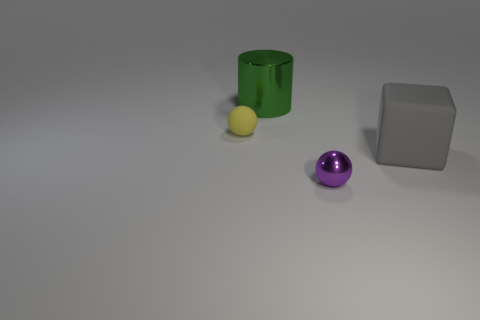Add 4 large gray things. How many objects exist? 8 Subtract all cylinders. How many objects are left? 3 Add 4 brown blocks. How many brown blocks exist? 4 Subtract 1 green cylinders. How many objects are left? 3 Subtract all tiny purple metal things. Subtract all gray objects. How many objects are left? 2 Add 1 big gray rubber blocks. How many big gray rubber blocks are left? 2 